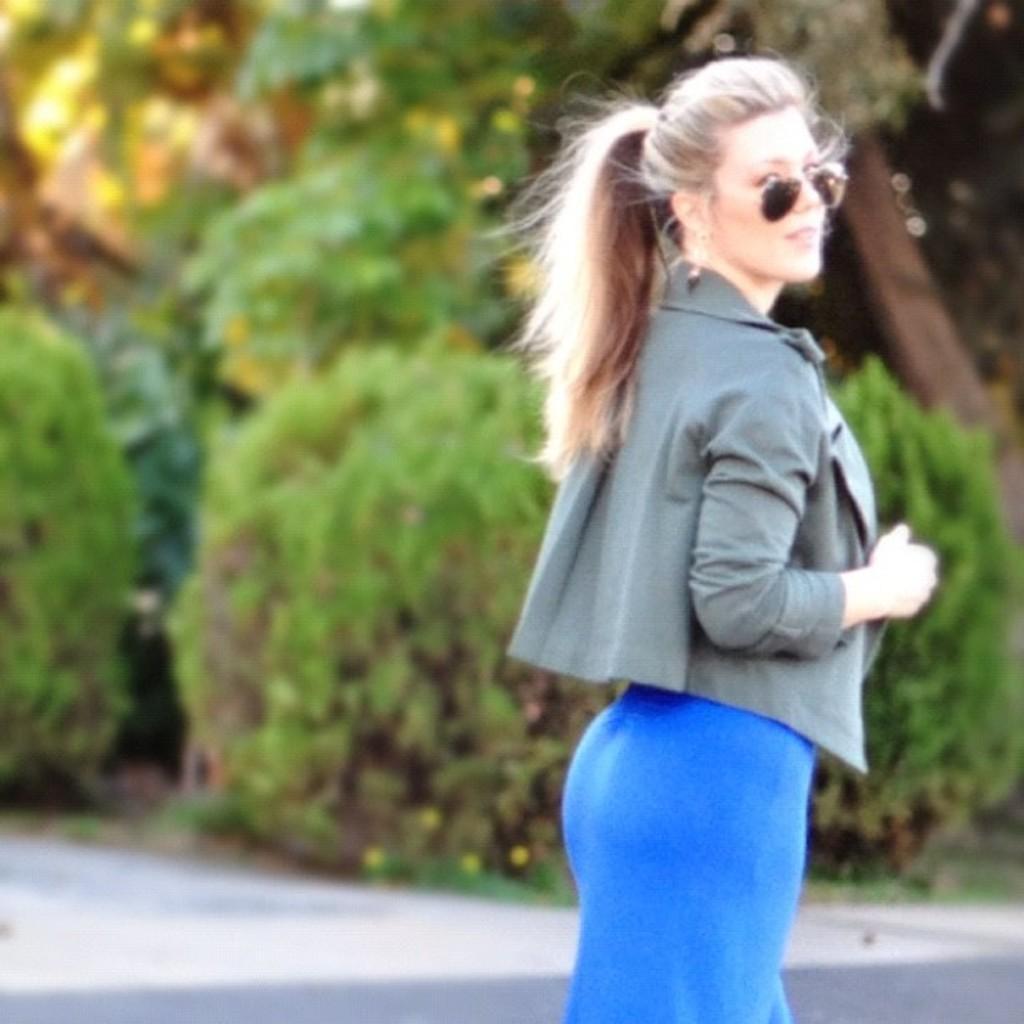Can you describe this image briefly? In the picture there is a woman standing on the road and posing for the photo, she is also wearing goggles and in the background there are many trees. 